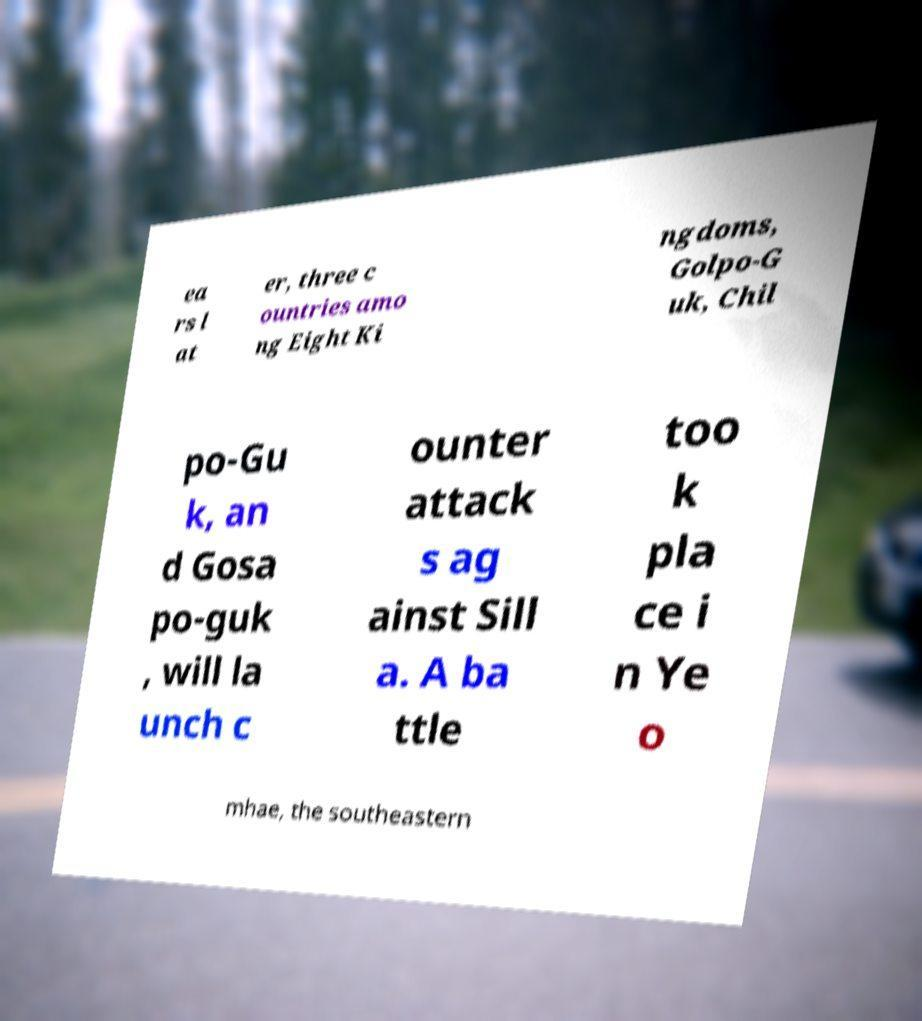For documentation purposes, I need the text within this image transcribed. Could you provide that? ea rs l at er, three c ountries amo ng Eight Ki ngdoms, Golpo-G uk, Chil po-Gu k, an d Gosa po-guk , will la unch c ounter attack s ag ainst Sill a. A ba ttle too k pla ce i n Ye o mhae, the southeastern 